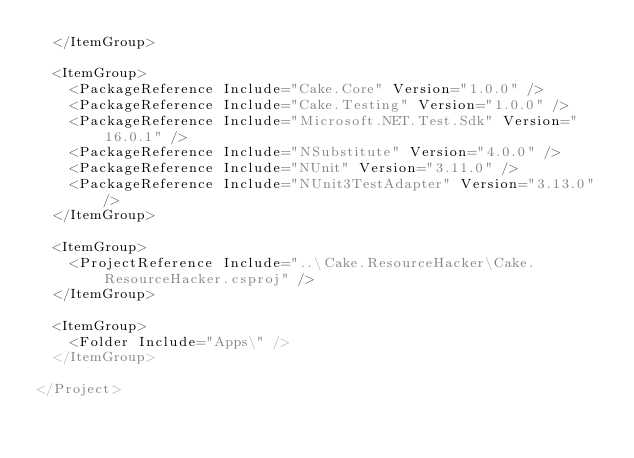Convert code to text. <code><loc_0><loc_0><loc_500><loc_500><_XML_>  </ItemGroup>

  <ItemGroup>
    <PackageReference Include="Cake.Core" Version="1.0.0" />
    <PackageReference Include="Cake.Testing" Version="1.0.0" />
    <PackageReference Include="Microsoft.NET.Test.Sdk" Version="16.0.1" />
    <PackageReference Include="NSubstitute" Version="4.0.0" />
    <PackageReference Include="NUnit" Version="3.11.0" />
    <PackageReference Include="NUnit3TestAdapter" Version="3.13.0" />
  </ItemGroup>

  <ItemGroup>
    <ProjectReference Include="..\Cake.ResourceHacker\Cake.ResourceHacker.csproj" />
  </ItemGroup>

  <ItemGroup>
    <Folder Include="Apps\" />
  </ItemGroup>

</Project>
</code> 